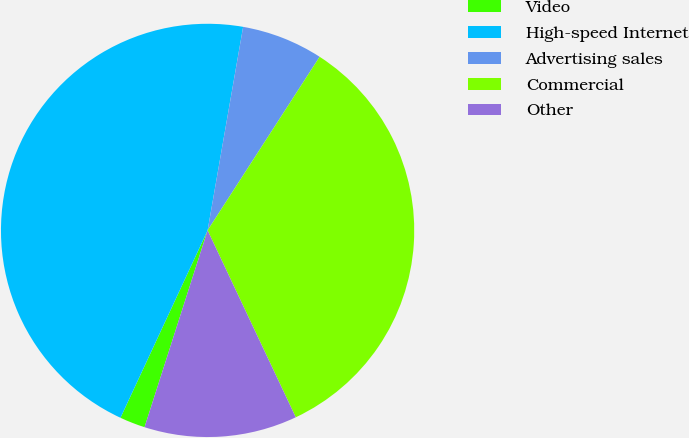Convert chart. <chart><loc_0><loc_0><loc_500><loc_500><pie_chart><fcel>Video<fcel>High-speed Internet<fcel>Advertising sales<fcel>Commercial<fcel>Other<nl><fcel>1.99%<fcel>45.82%<fcel>6.37%<fcel>33.86%<fcel>11.95%<nl></chart> 